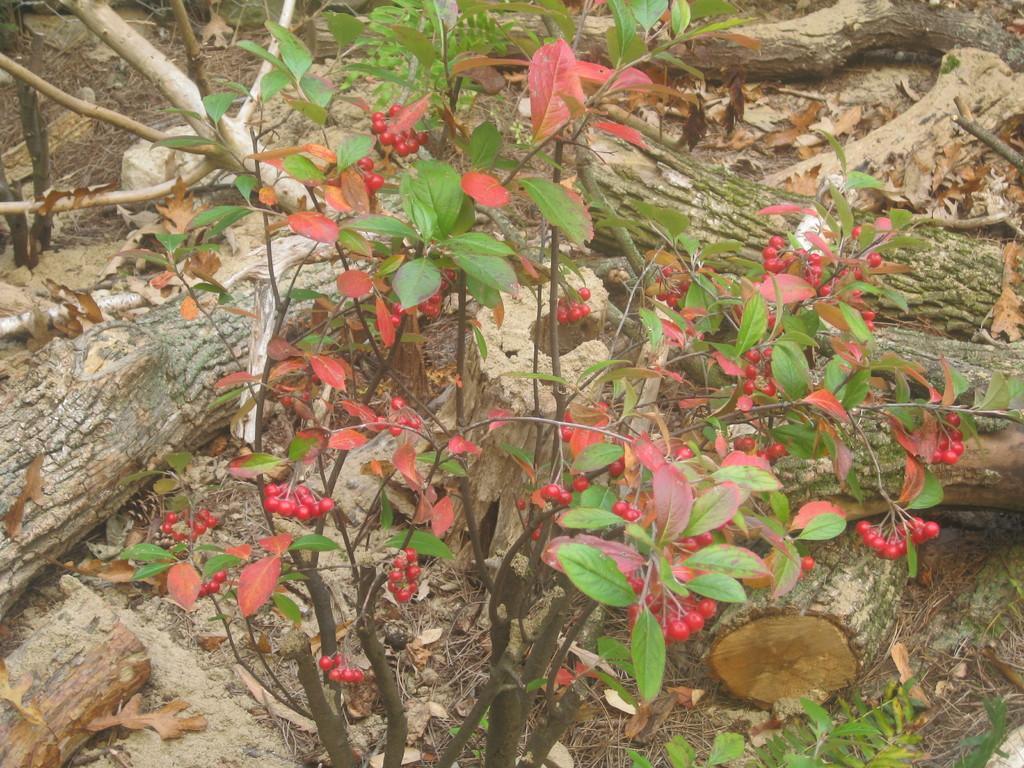How would you summarize this image in a sentence or two? In this image we can see plant and branches. 